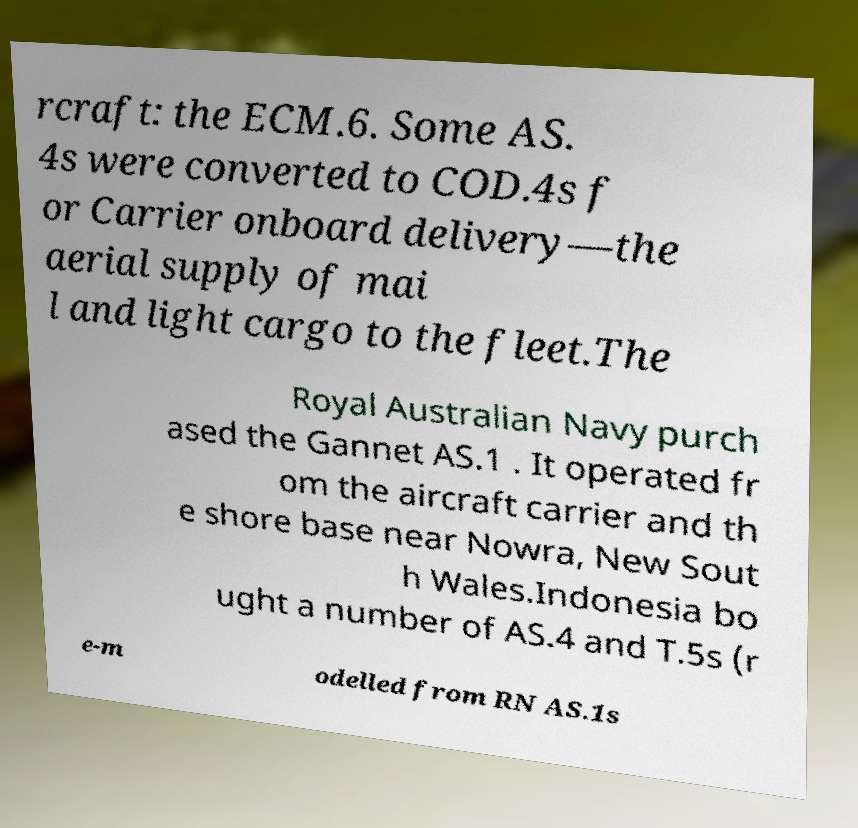Can you accurately transcribe the text from the provided image for me? rcraft: the ECM.6. Some AS. 4s were converted to COD.4s f or Carrier onboard delivery—the aerial supply of mai l and light cargo to the fleet.The Royal Australian Navy purch ased the Gannet AS.1 . It operated fr om the aircraft carrier and th e shore base near Nowra, New Sout h Wales.Indonesia bo ught a number of AS.4 and T.5s (r e-m odelled from RN AS.1s 